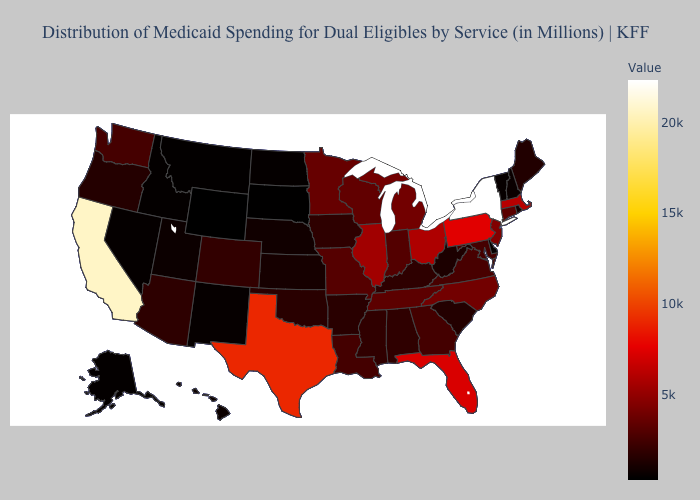Does North Dakota have a lower value than Florida?
Quick response, please. Yes. Does Florida have the lowest value in the USA?
Keep it brief. No. Does the map have missing data?
Answer briefly. No. Among the states that border Kentucky , which have the lowest value?
Be succinct. West Virginia. 